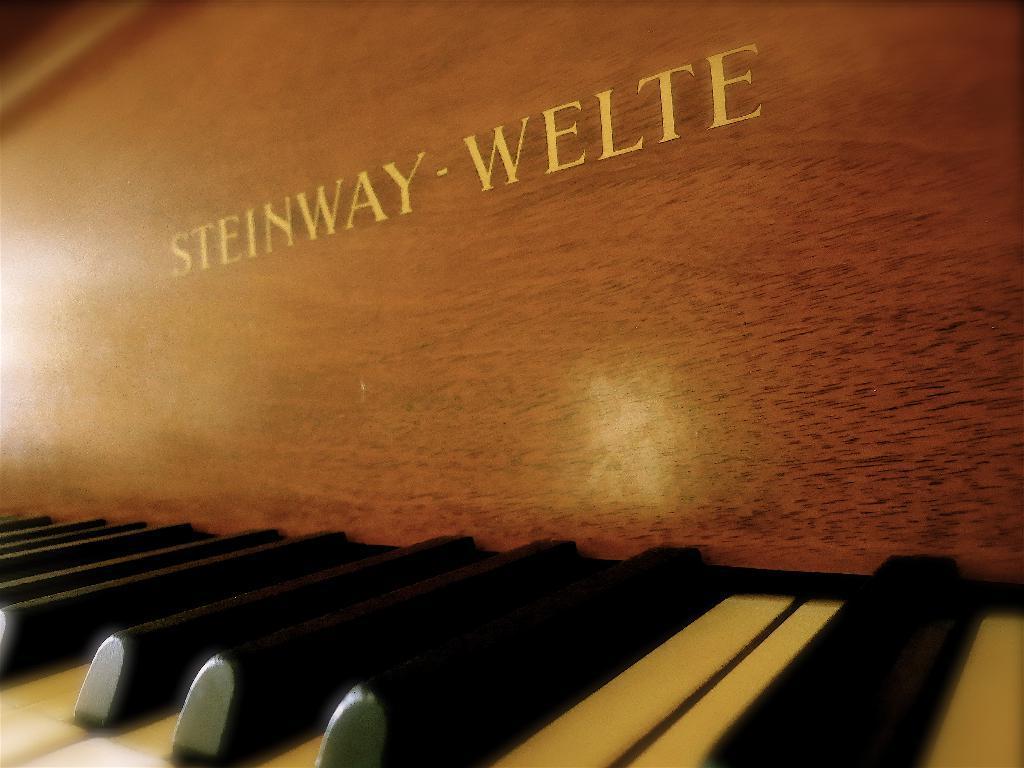Please provide a concise description of this image. There is a piano in this given picture with black and white keys are, made up of wood. 